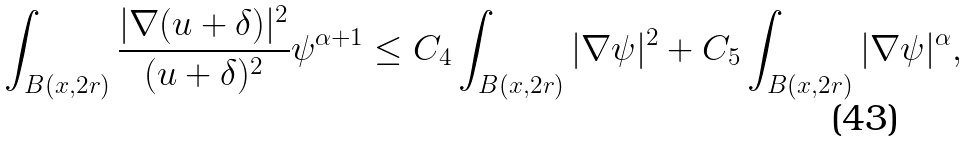<formula> <loc_0><loc_0><loc_500><loc_500>\int _ { B ( x , 2 r ) } \frac { | \nabla ( u + \delta ) | ^ { 2 } } { ( u + \delta ) ^ { 2 } } \psi ^ { \alpha + 1 } \leq C _ { 4 } \int _ { B ( x , 2 r ) } | \nabla \psi | ^ { 2 } + C _ { 5 } \int _ { B ( x , 2 r ) } | \nabla \psi | ^ { \alpha } ,</formula> 